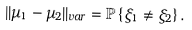<formula> <loc_0><loc_0><loc_500><loc_500>| | \mu _ { 1 } - \mu _ { 2 } | | _ { v a r } = { \mathbb { P } } \left \{ \xi _ { 1 } \neq \xi _ { 2 } \right \} .</formula> 